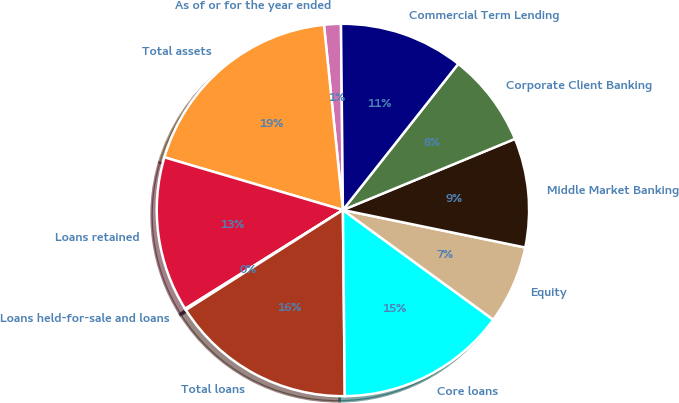Convert chart to OTSL. <chart><loc_0><loc_0><loc_500><loc_500><pie_chart><fcel>As of or for the year ended<fcel>Total assets<fcel>Loans retained<fcel>Loans held-for-sale and loans<fcel>Total loans<fcel>Core loans<fcel>Equity<fcel>Middle Market Banking<fcel>Corporate Client Banking<fcel>Commercial Term Lending<nl><fcel>1.46%<fcel>18.81%<fcel>13.47%<fcel>0.12%<fcel>16.14%<fcel>14.81%<fcel>6.8%<fcel>9.47%<fcel>8.13%<fcel>10.8%<nl></chart> 